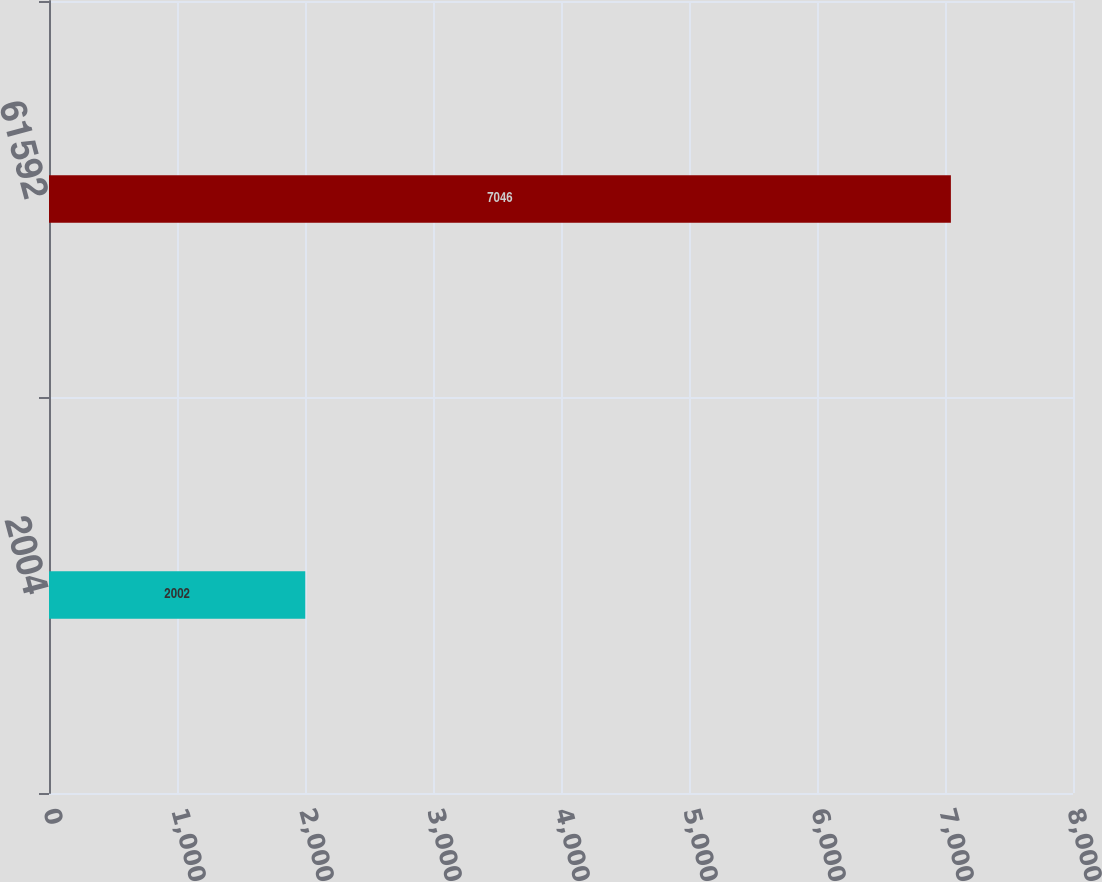Convert chart to OTSL. <chart><loc_0><loc_0><loc_500><loc_500><bar_chart><fcel>2004<fcel>61592<nl><fcel>2002<fcel>7046<nl></chart> 